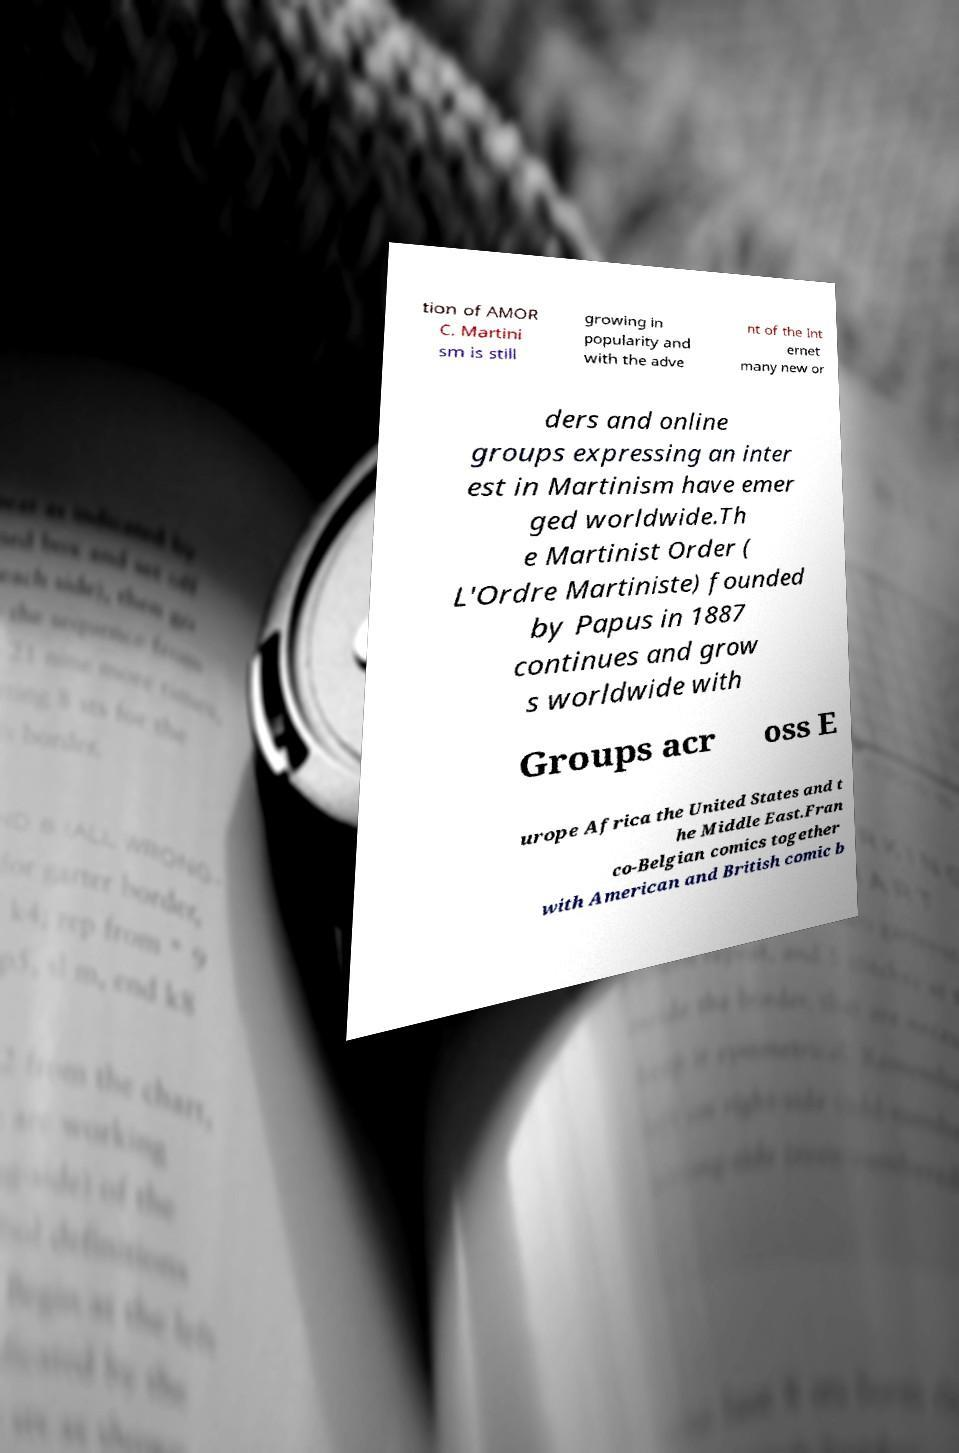There's text embedded in this image that I need extracted. Can you transcribe it verbatim? tion of AMOR C. Martini sm is still growing in popularity and with the adve nt of the Int ernet many new or ders and online groups expressing an inter est in Martinism have emer ged worldwide.Th e Martinist Order ( L'Ordre Martiniste) founded by Papus in 1887 continues and grow s worldwide with Groups acr oss E urope Africa the United States and t he Middle East.Fran co-Belgian comics together with American and British comic b 